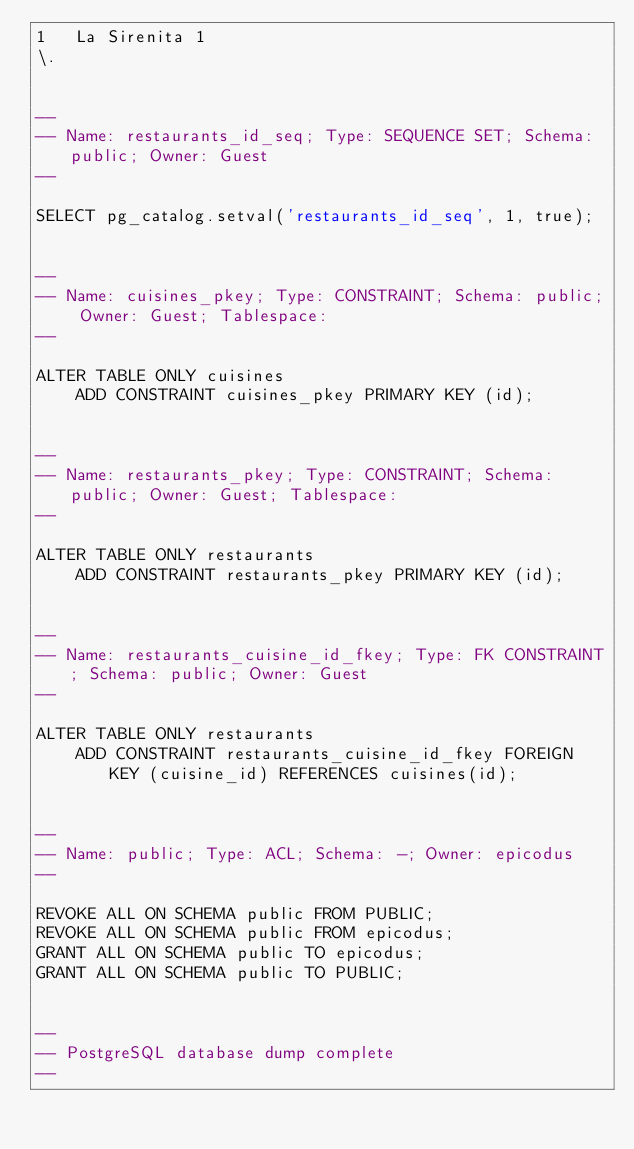<code> <loc_0><loc_0><loc_500><loc_500><_SQL_>1	La Sirenita	1
\.


--
-- Name: restaurants_id_seq; Type: SEQUENCE SET; Schema: public; Owner: Guest
--

SELECT pg_catalog.setval('restaurants_id_seq', 1, true);


--
-- Name: cuisines_pkey; Type: CONSTRAINT; Schema: public; Owner: Guest; Tablespace: 
--

ALTER TABLE ONLY cuisines
    ADD CONSTRAINT cuisines_pkey PRIMARY KEY (id);


--
-- Name: restaurants_pkey; Type: CONSTRAINT; Schema: public; Owner: Guest; Tablespace: 
--

ALTER TABLE ONLY restaurants
    ADD CONSTRAINT restaurants_pkey PRIMARY KEY (id);


--
-- Name: restaurants_cuisine_id_fkey; Type: FK CONSTRAINT; Schema: public; Owner: Guest
--

ALTER TABLE ONLY restaurants
    ADD CONSTRAINT restaurants_cuisine_id_fkey FOREIGN KEY (cuisine_id) REFERENCES cuisines(id);


--
-- Name: public; Type: ACL; Schema: -; Owner: epicodus
--

REVOKE ALL ON SCHEMA public FROM PUBLIC;
REVOKE ALL ON SCHEMA public FROM epicodus;
GRANT ALL ON SCHEMA public TO epicodus;
GRANT ALL ON SCHEMA public TO PUBLIC;


--
-- PostgreSQL database dump complete
--

</code> 